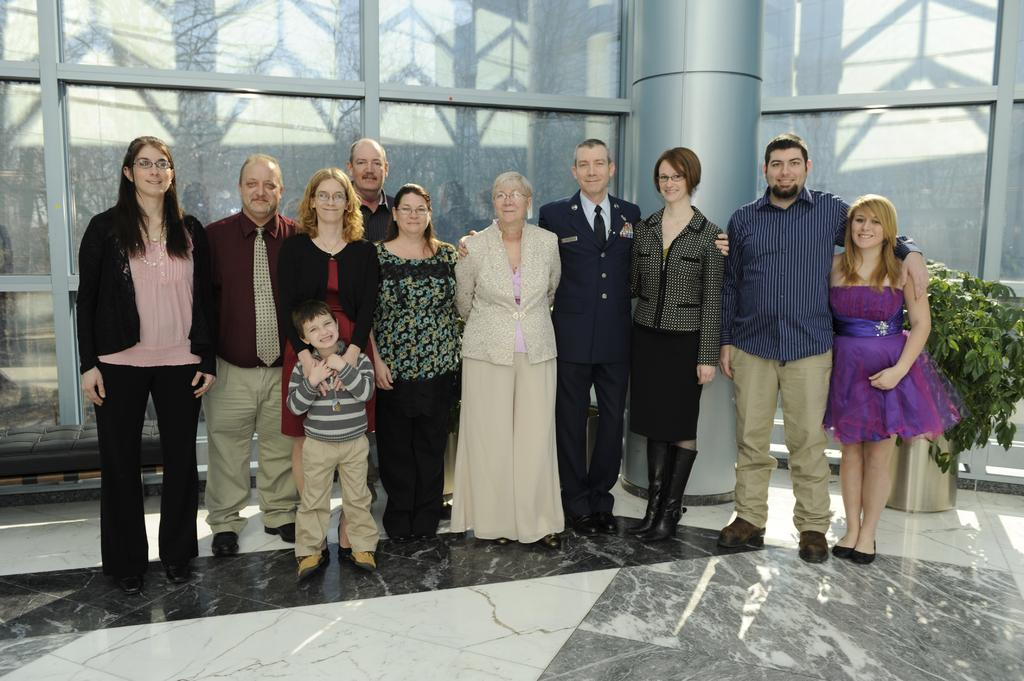What can be seen in the image? There are people standing in the image. Where are the people standing? The people are standing on the floor. What can be seen in the background of the image? There is a glass wall, a pillar, and a plant in the background of the image. What type of metal is the mitten made of in the image? There is no mitten present in the image, so it is not possible to determine what type of metal it might be made of. 